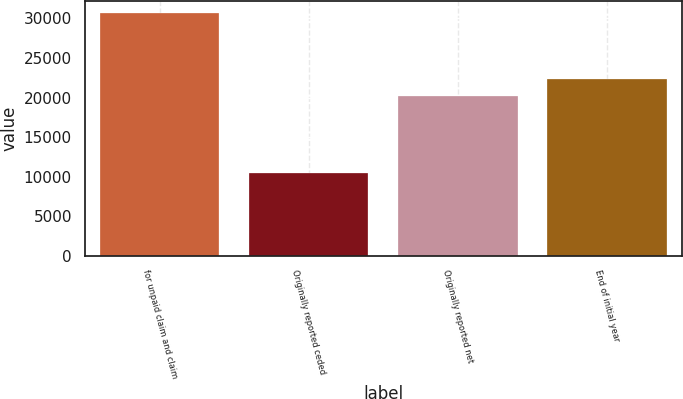<chart> <loc_0><loc_0><loc_500><loc_500><bar_chart><fcel>for unpaid claim and claim<fcel>Originally reported ceded<fcel>Originally reported net<fcel>End of initial year<nl><fcel>30694<fcel>10438<fcel>20256<fcel>22281.6<nl></chart> 